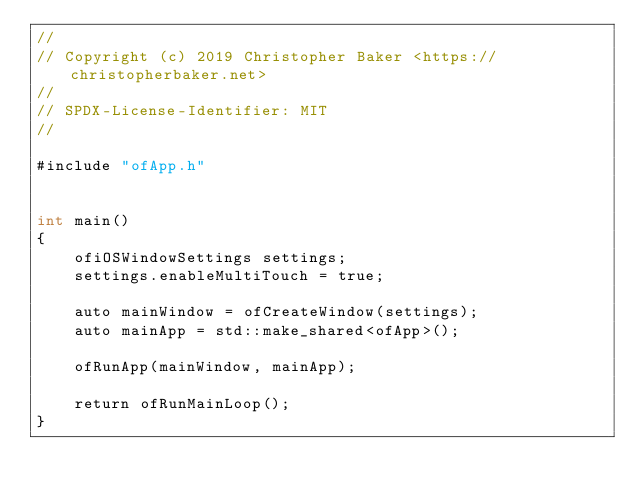<code> <loc_0><loc_0><loc_500><loc_500><_ObjectiveC_>//
// Copyright (c) 2019 Christopher Baker <https://christopherbaker.net>
//
// SPDX-License-Identifier:	MIT
//

#include "ofApp.h"


int main()
{
    ofiOSWindowSettings settings;
    settings.enableMultiTouch = true;

    auto mainWindow = ofCreateWindow(settings);
    auto mainApp = std::make_shared<ofApp>();

    ofRunApp(mainWindow, mainApp);

    return ofRunMainLoop();
}
</code> 